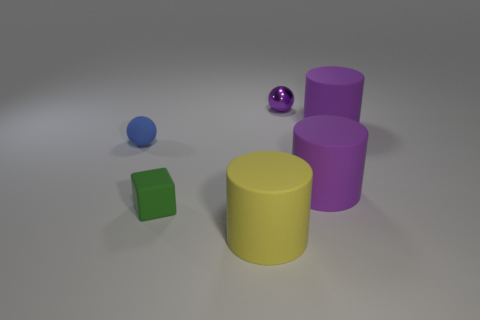What size is the yellow thing that is made of the same material as the tiny blue thing?
Provide a short and direct response. Large. Do the large matte object that is left of the tiny purple shiny thing and the ball in front of the purple shiny sphere have the same color?
Give a very brief answer. No. There is a cylinder that is in front of the small green cube; what number of small blue balls are to the right of it?
Provide a short and direct response. 0. Are any tiny green rubber objects visible?
Your answer should be very brief. Yes. What number of other things are the same color as the tiny metallic object?
Your answer should be very brief. 2. Is the number of tiny green matte things less than the number of red rubber things?
Offer a terse response. No. What shape is the tiny purple thing behind the large matte cylinder in front of the cube?
Provide a succinct answer. Sphere. Are there any metal balls in front of the yellow rubber thing?
Offer a very short reply. No. There is a matte sphere that is the same size as the green rubber object; what color is it?
Your response must be concise. Blue. What number of blue objects have the same material as the small green thing?
Offer a terse response. 1. 